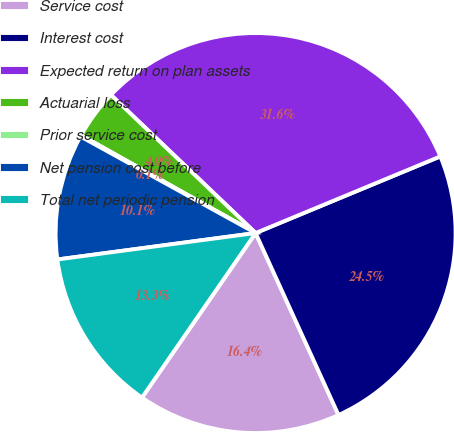Convert chart. <chart><loc_0><loc_0><loc_500><loc_500><pie_chart><fcel>Service cost<fcel>Interest cost<fcel>Expected return on plan assets<fcel>Actuarial loss<fcel>Prior service cost<fcel>Net pension cost before<fcel>Total net periodic pension<nl><fcel>16.42%<fcel>24.45%<fcel>31.61%<fcel>4.0%<fcel>0.11%<fcel>10.13%<fcel>13.27%<nl></chart> 